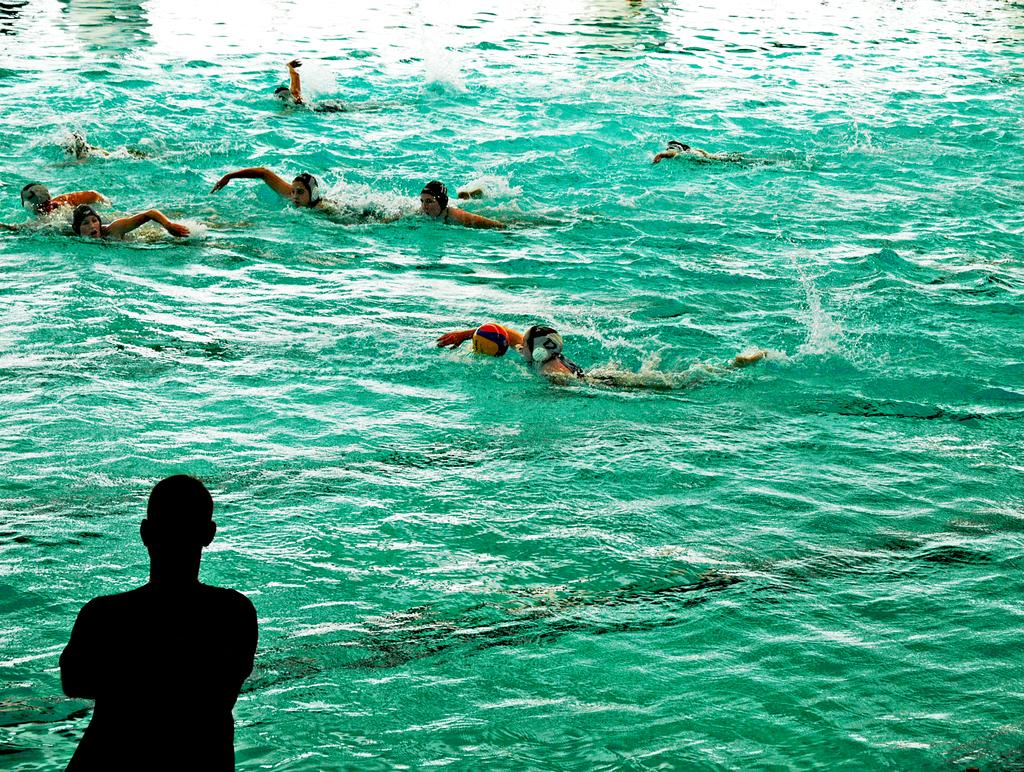What is the main element in the image? There is water in the image. What are the people in the water doing? The people swimming in the water are wearing head caps. Can you describe the person standing in the image? There is a person standing in the image, but no specific details are provided about their appearance or actions. What type of fiction is being read by the person standing in the image? There is no indication in the image that the person standing is reading any fiction, as the focus is on the water and people swimming. 